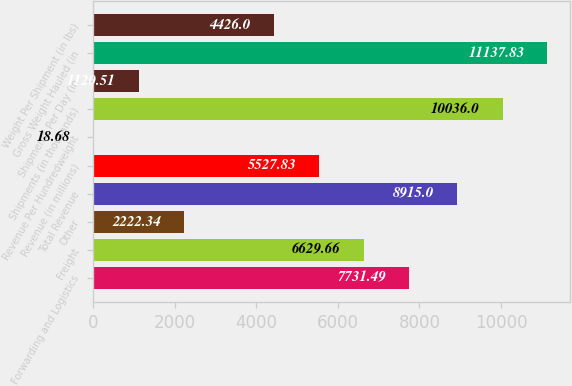<chart> <loc_0><loc_0><loc_500><loc_500><bar_chart><fcel>Forwarding and Logistics<fcel>Freight<fcel>Other<fcel>Total Revenue<fcel>Revenue (in millions)<fcel>Revenue Per Hundredweight<fcel>Shipments (in thousands)<fcel>Shipments Per Day (in<fcel>Gross Weight Hauled (in<fcel>Weight Per Shipment (in lbs)<nl><fcel>7731.49<fcel>6629.66<fcel>2222.34<fcel>8915<fcel>5527.83<fcel>18.68<fcel>10036<fcel>1120.51<fcel>11137.8<fcel>4426<nl></chart> 